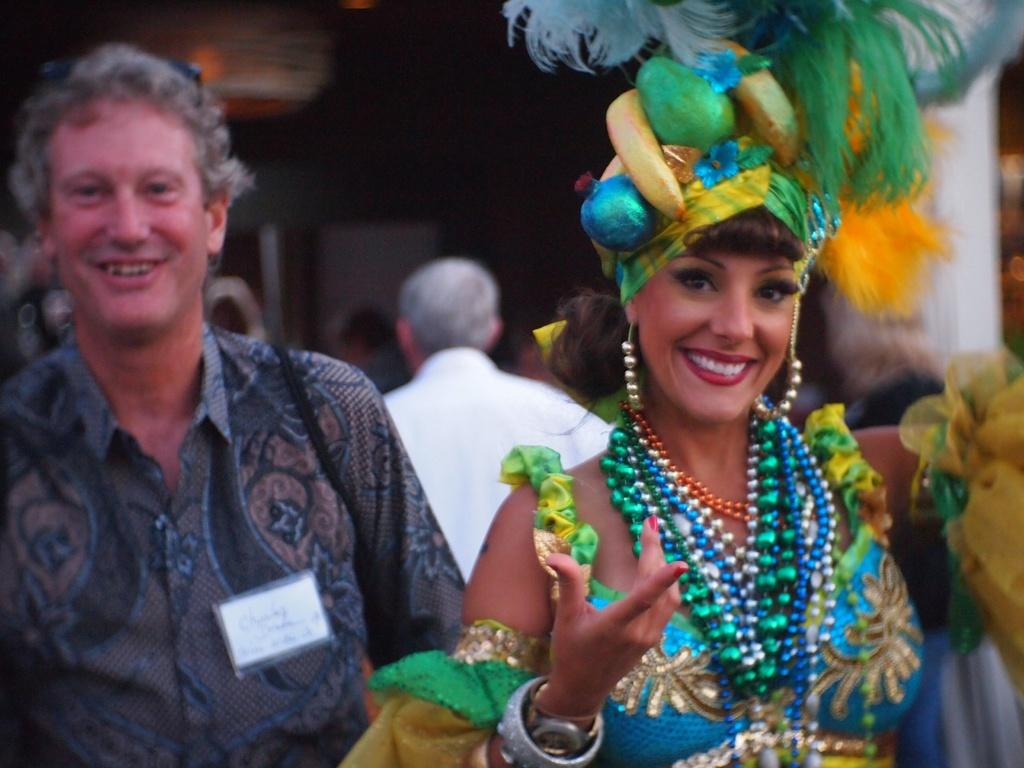What are the women in the image wearing? The women in the image are wearing different costumes. What are the persons in the image doing? The persons in the image are walking. What type of wine is being served at the station in the image? There is no wine or station present in the image; it features women wearing different costumes and persons walking. 